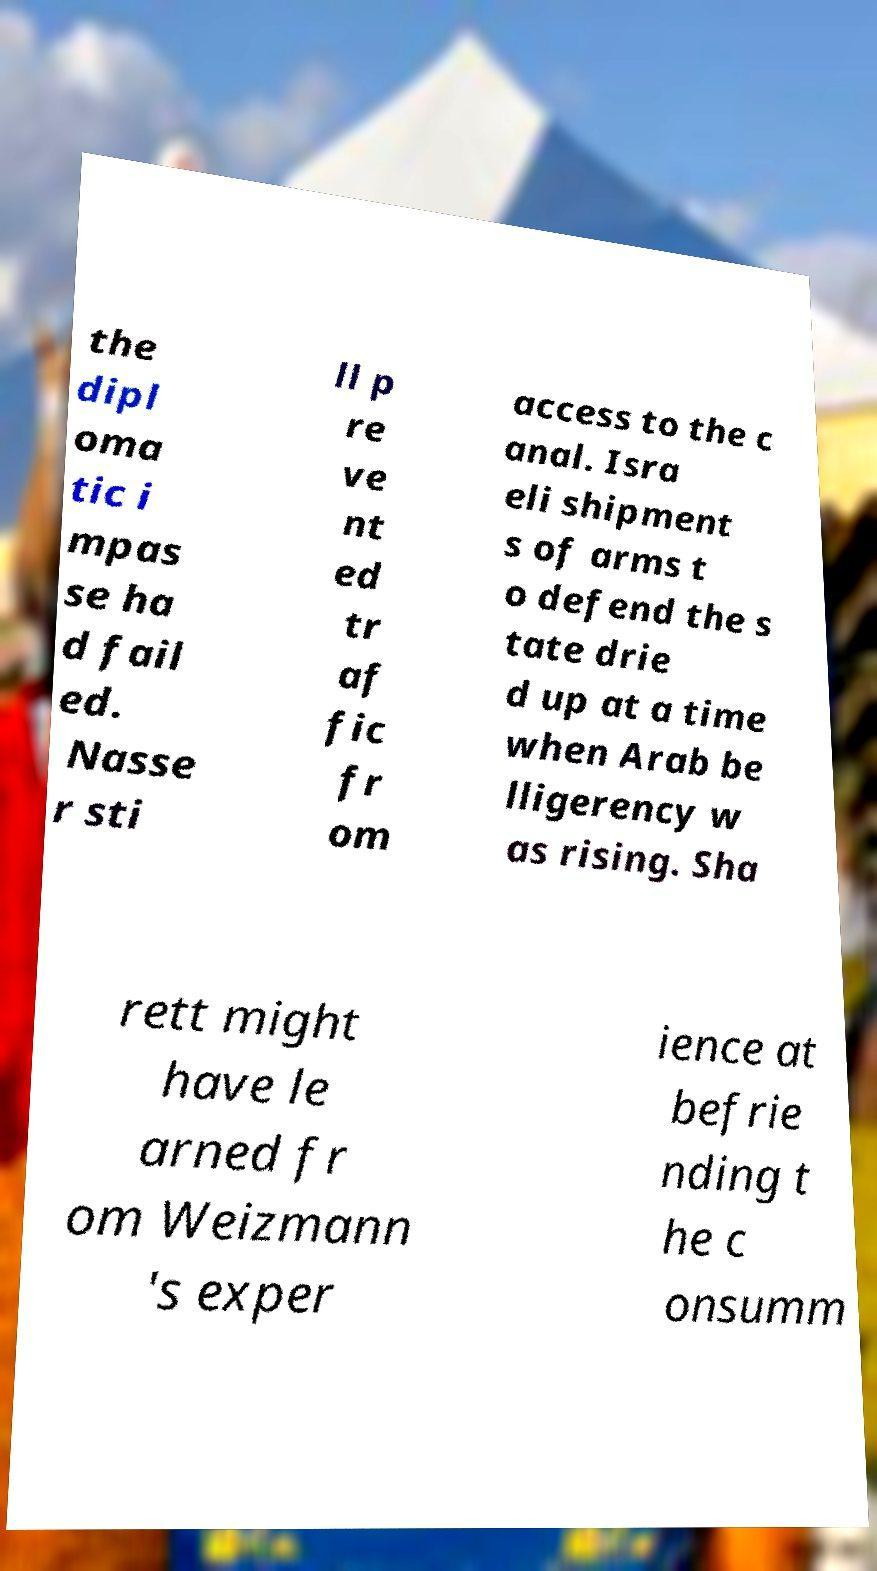Can you read and provide the text displayed in the image?This photo seems to have some interesting text. Can you extract and type it out for me? the dipl oma tic i mpas se ha d fail ed. Nasse r sti ll p re ve nt ed tr af fic fr om access to the c anal. Isra eli shipment s of arms t o defend the s tate drie d up at a time when Arab be lligerency w as rising. Sha rett might have le arned fr om Weizmann 's exper ience at befrie nding t he c onsumm 